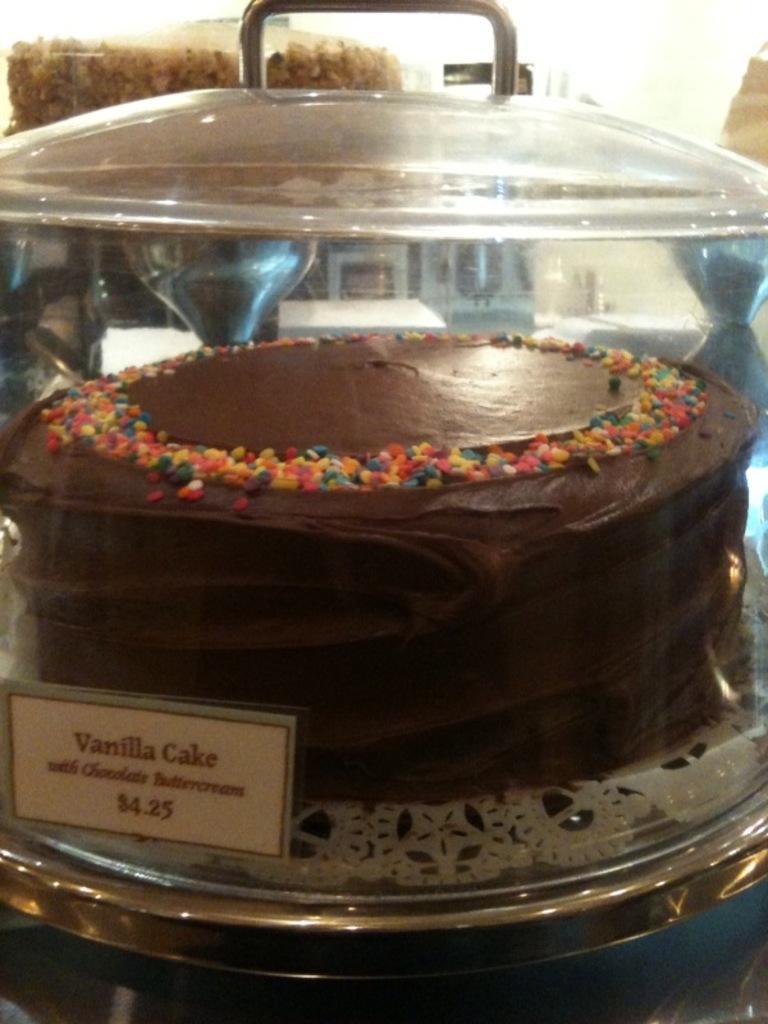In one or two sentences, can you explain what this image depicts? In this image, I can see a cake, which is kept on the cake stand. This cake is covered with a glass lid. I think this is a price board. 